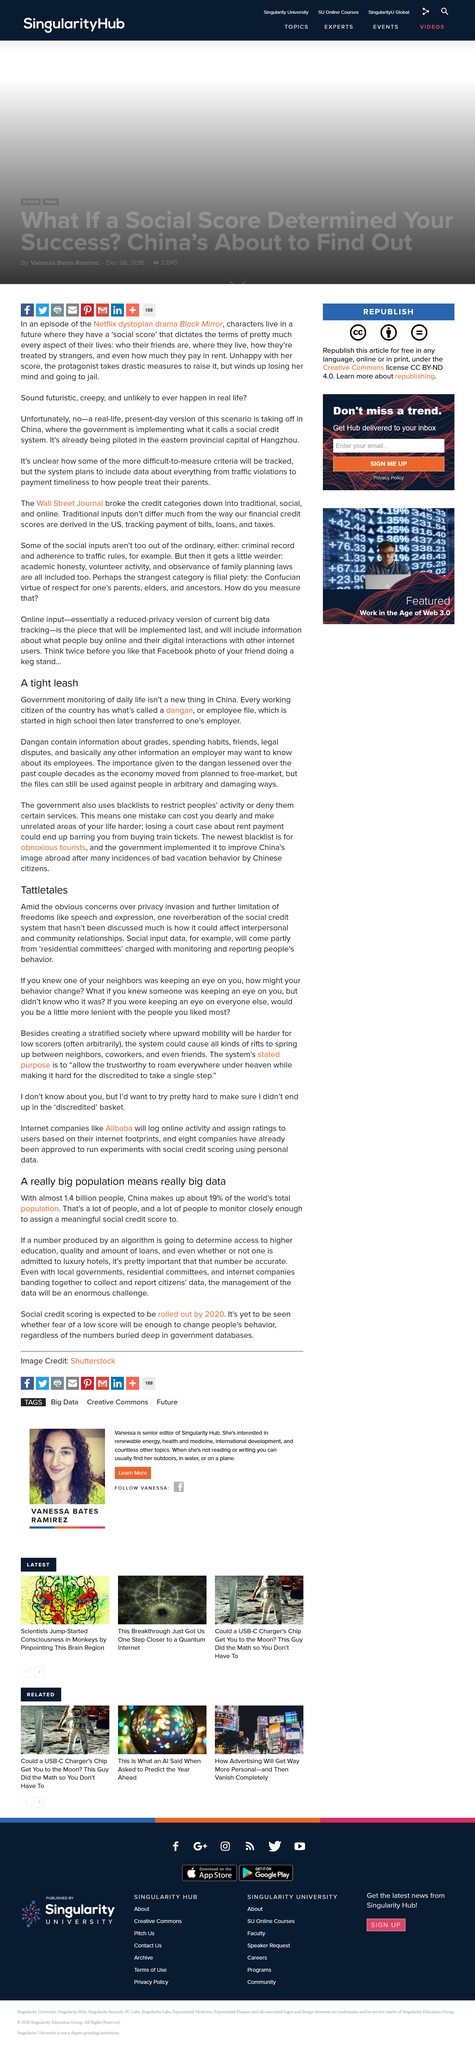Specify some key components in this picture. My behavior could potentially change because I am aware that one of my neighbors is keeping watch over me. When is a dangan started? A dangan is typically started in high school. The population of China is approximately 1.4 billion people. The stated purpose of this system is to facilitate the free movement of trustworthy individuals throughout the land, while simultaneously hindering the ability of discredited individuals to travel even a short distance. The social credit system is based on citizens reporting the behavior of their fellow citizens to "residential committees," which then monitor and assess the reported behavior to assign a score to the individual. 